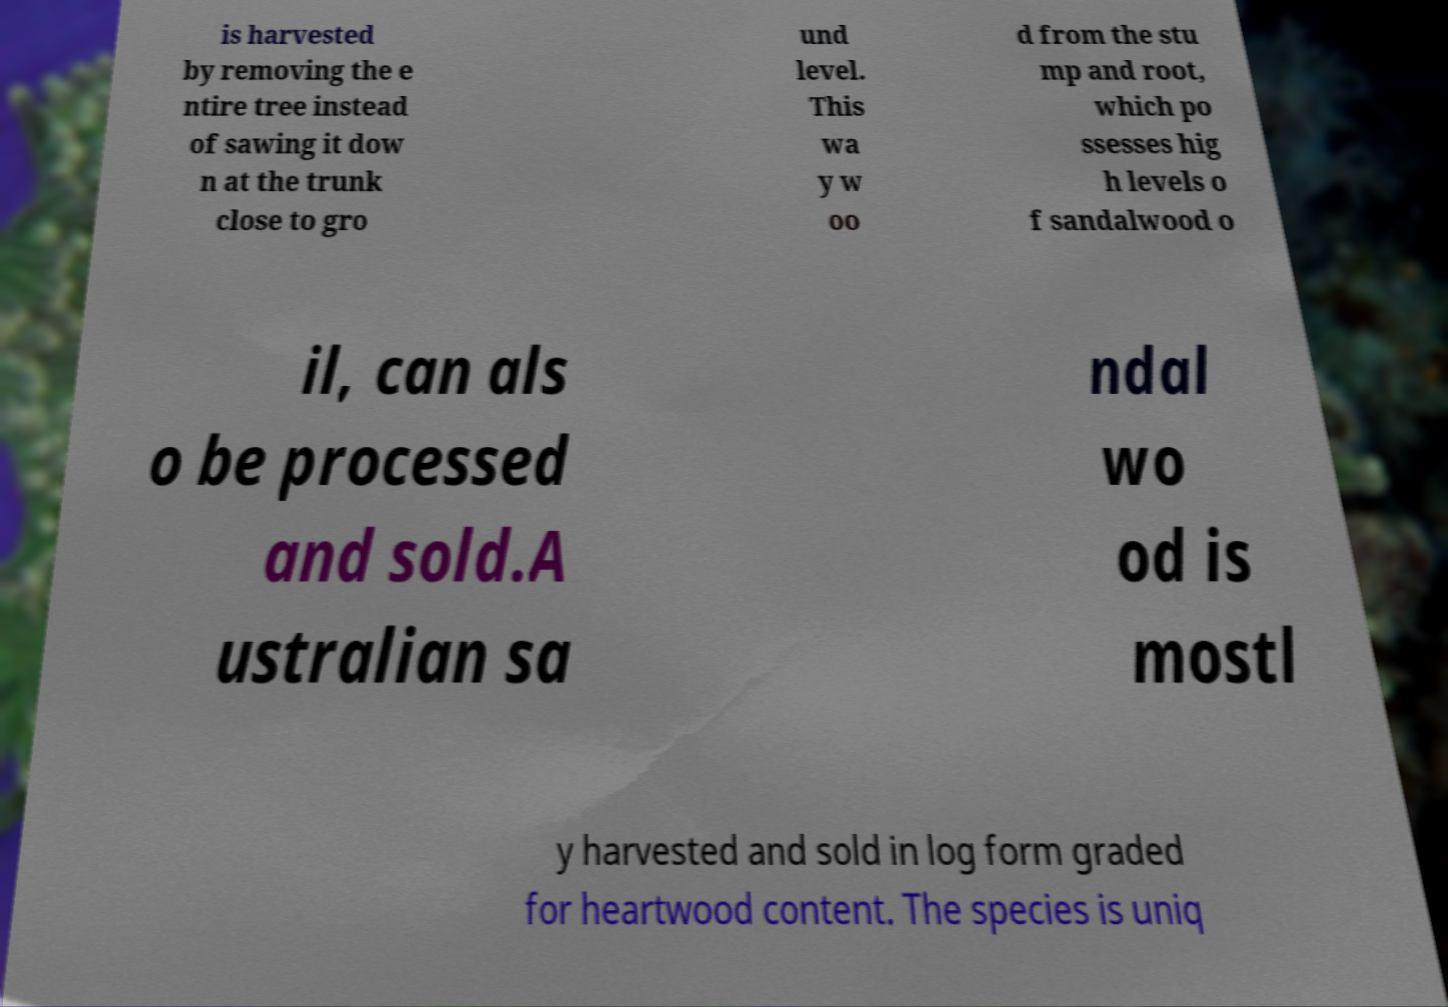Can you read and provide the text displayed in the image?This photo seems to have some interesting text. Can you extract and type it out for me? is harvested by removing the e ntire tree instead of sawing it dow n at the trunk close to gro und level. This wa y w oo d from the stu mp and root, which po ssesses hig h levels o f sandalwood o il, can als o be processed and sold.A ustralian sa ndal wo od is mostl y harvested and sold in log form graded for heartwood content. The species is uniq 